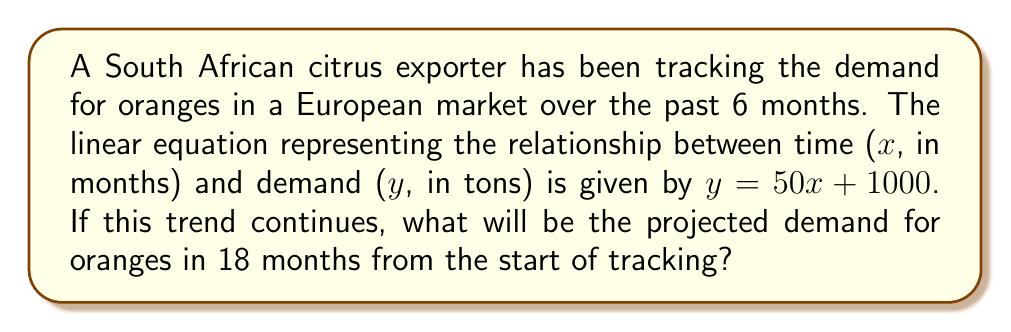Help me with this question. To solve this problem, we need to use the given linear equation and substitute the appropriate value for x. Let's break it down step-by-step:

1. The linear equation is given as:
   $y = 50x + 1000$

   Where:
   $y$ = demand in tons
   $x$ = time in months
   $50$ = slope (rate of change in demand per month)
   $1000$ = y-intercept (initial demand at x = 0)

2. We need to find the demand after 18 months, so we substitute $x = 18$ into the equation:

   $y = 50(18) + 1000$

3. Simplify the multiplication:
   $y = 900 + 1000$

4. Add the terms:
   $y = 1900$

Therefore, the projected demand for oranges in 18 months from the start of tracking will be 1900 tons.
Answer: 1900 tons 